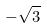<formula> <loc_0><loc_0><loc_500><loc_500>- \sqrt { 3 }</formula> 